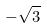<formula> <loc_0><loc_0><loc_500><loc_500>- \sqrt { 3 }</formula> 